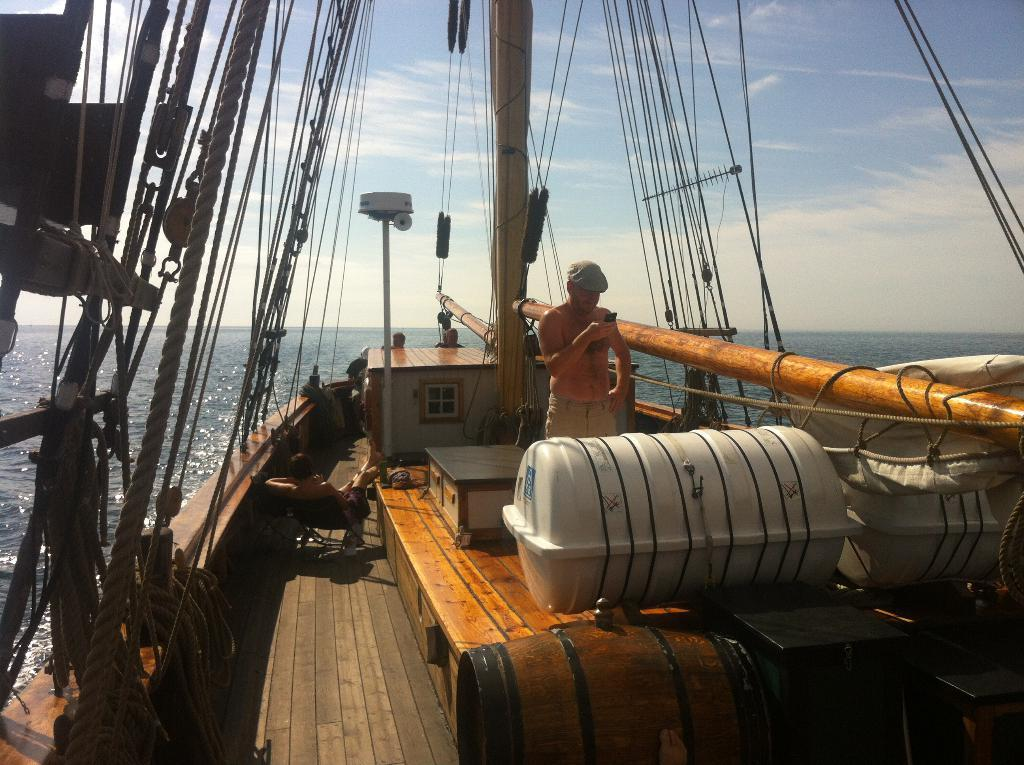What is the main element present in the image? There is water in the image. What objects can be seen related to water activities? There is a ski and a boat in the image. What other items are visible in the image? There are containers and a chair in the image. How many people are present in the image? There are two people in the image. What type of stitch is being used by the person in the image? There is no person sewing or using a stitch in the image. Can you describe the truck that is parked near the water? There is no truck present in the image. 